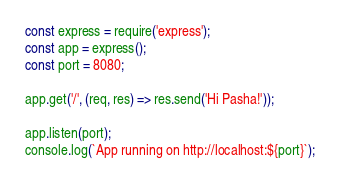<code> <loc_0><loc_0><loc_500><loc_500><_JavaScript_>const express = require('express');
const app = express();
const port = 8080;

app.get('/', (req, res) => res.send('Hi Pasha!'));

app.listen(port);
console.log(`App running on http://localhost:${port}`);
</code> 